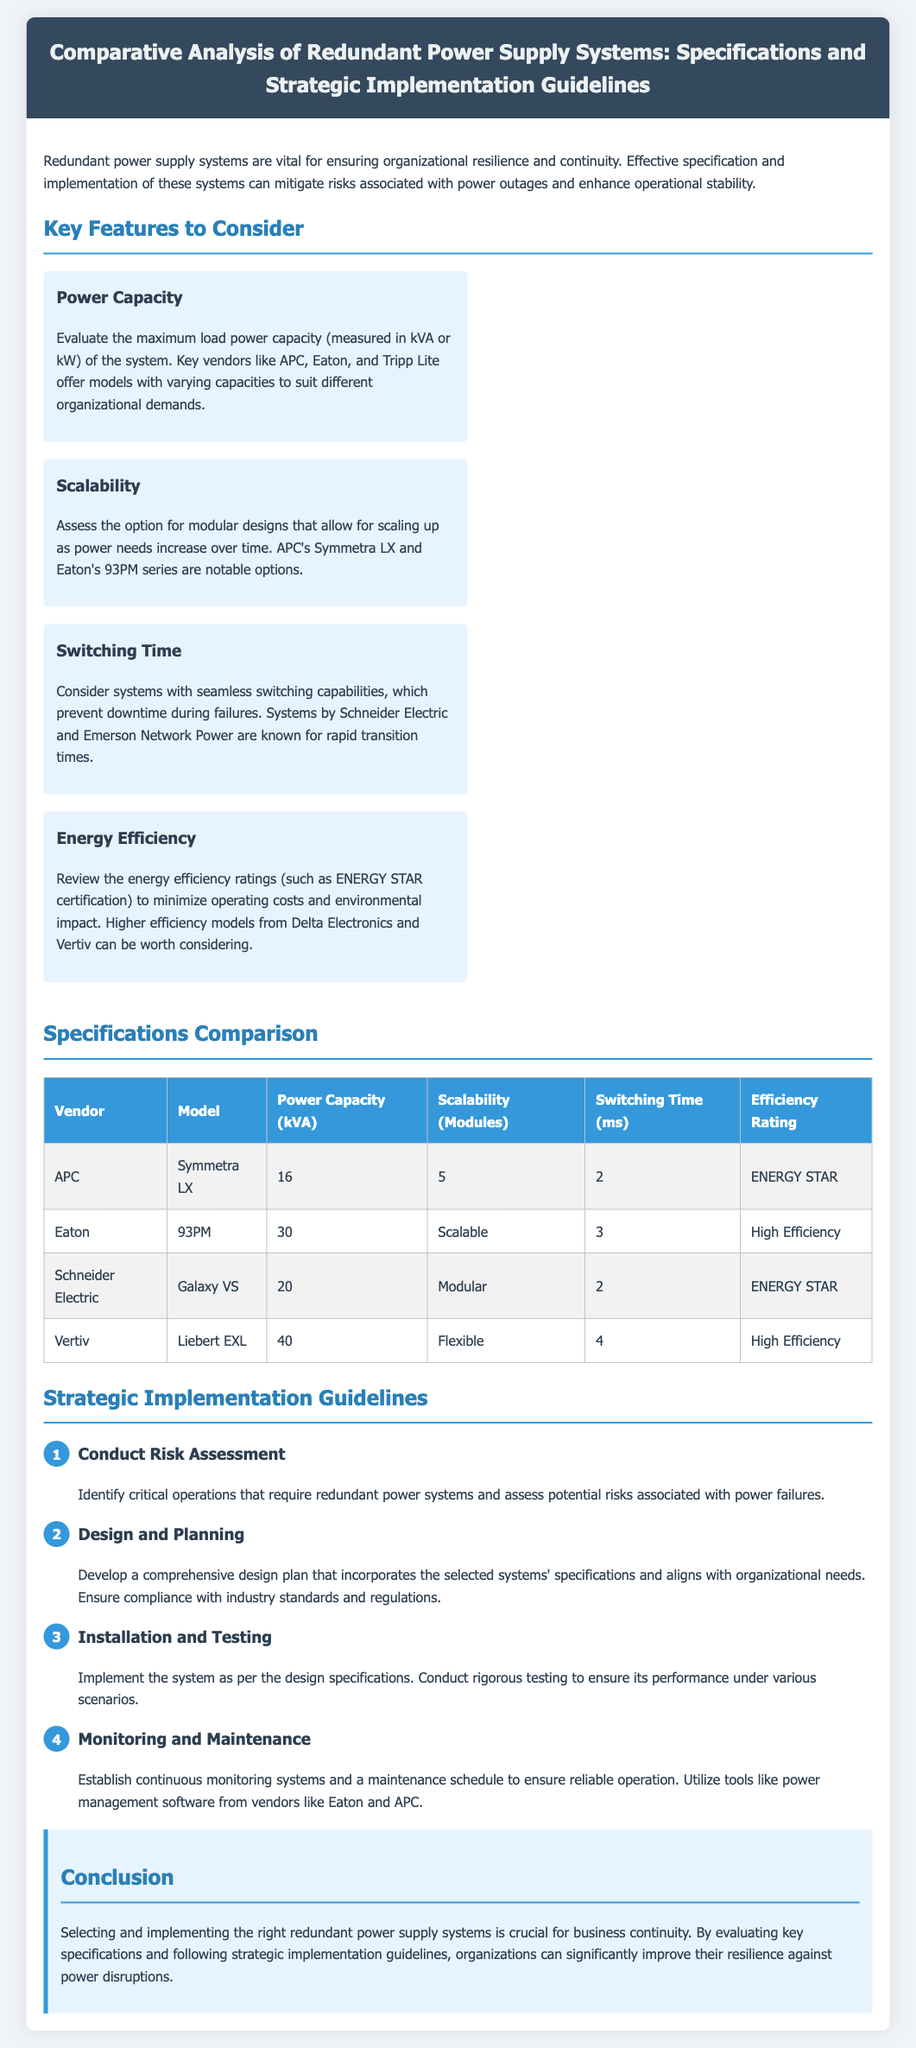What is the title of the document? The title is specified in the header of the document and denotes the subject matter covered in the document.
Answer: Comparative Analysis of Redundant Power Supply Systems: Specifications and Strategic Implementation Guidelines Which vendor offers the Symmetra LX model? The vendor information is listed in the specifications comparison table, which aligns models with their respective manufacturers.
Answer: APC How many power capacity (kVA) does the Liebert EXL model have? The power capacity for each model is provided in the specifications comparison table, allowing quick reference to the capacity associated with each vendor and model.
Answer: 40 What is the efficiency rating of the Galaxy VS model? The efficiency ratings for each system are presented in the specifications comparison table, detailing the efficiency levels of various models.
Answer: ENERGY STAR What is the first step in the strategic implementation guidelines? The first step is outlined in the implementation guidelines section, which details the process for deploying a redundant power supply system.
Answer: Conduct Risk Assessment How many modules can the Eaton 93PM be scaled? The scalability options for each model are provided in the specifications comparison table, indicating how many modules each system can accommodate for future expansion.
Answer: Scalable What is the switching time (ms) for the Symmetra LX? The switching time for each model is provided in the specifications comparison table, highlighting the performance of different systems concerning downtime during a power transition.
Answer: 2 Which two vendors are mentioned for power management software? Specific vendors are highlighted within the implementation guidelines to recommend tools for effective management and monitoring of redundant power systems.
Answer: Eaton and APC 